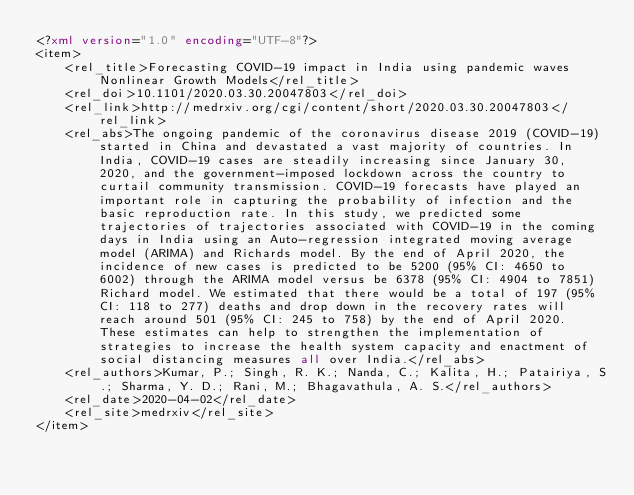<code> <loc_0><loc_0><loc_500><loc_500><_XML_><?xml version="1.0" encoding="UTF-8"?>
<item>
    <rel_title>Forecasting COVID-19 impact in India using pandemic waves Nonlinear Growth Models</rel_title>
    <rel_doi>10.1101/2020.03.30.20047803</rel_doi>
    <rel_link>http://medrxiv.org/cgi/content/short/2020.03.30.20047803</rel_link>
    <rel_abs>The ongoing pandemic of the coronavirus disease 2019 (COVID-19) started in China and devastated a vast majority of countries. In India, COVID-19 cases are steadily increasing since January 30, 2020, and the government-imposed lockdown across the country to curtail community transmission. COVID-19 forecasts have played an important role in capturing the probability of infection and the basic reproduction rate. In this study, we predicted some trajectories of trajectories associated with COVID-19 in the coming days in India using an Auto-regression integrated moving average model (ARIMA) and Richards model. By the end of April 2020, the incidence of new cases is predicted to be 5200 (95% CI: 4650 to 6002) through the ARIMA model versus be 6378 (95% CI: 4904 to 7851) Richard model. We estimated that there would be a total of 197 (95% CI: 118 to 277) deaths and drop down in the recovery rates will reach around 501 (95% CI: 245 to 758) by the end of April 2020. These estimates can help to strengthen the implementation of strategies to increase the health system capacity and enactment of social distancing measures all over India.</rel_abs>
    <rel_authors>Kumar, P.; Singh, R. K.; Nanda, C.; Kalita, H.; Patairiya, S.; Sharma, Y. D.; Rani, M.; Bhagavathula, A. S.</rel_authors>
    <rel_date>2020-04-02</rel_date>
    <rel_site>medrxiv</rel_site>
</item></code> 